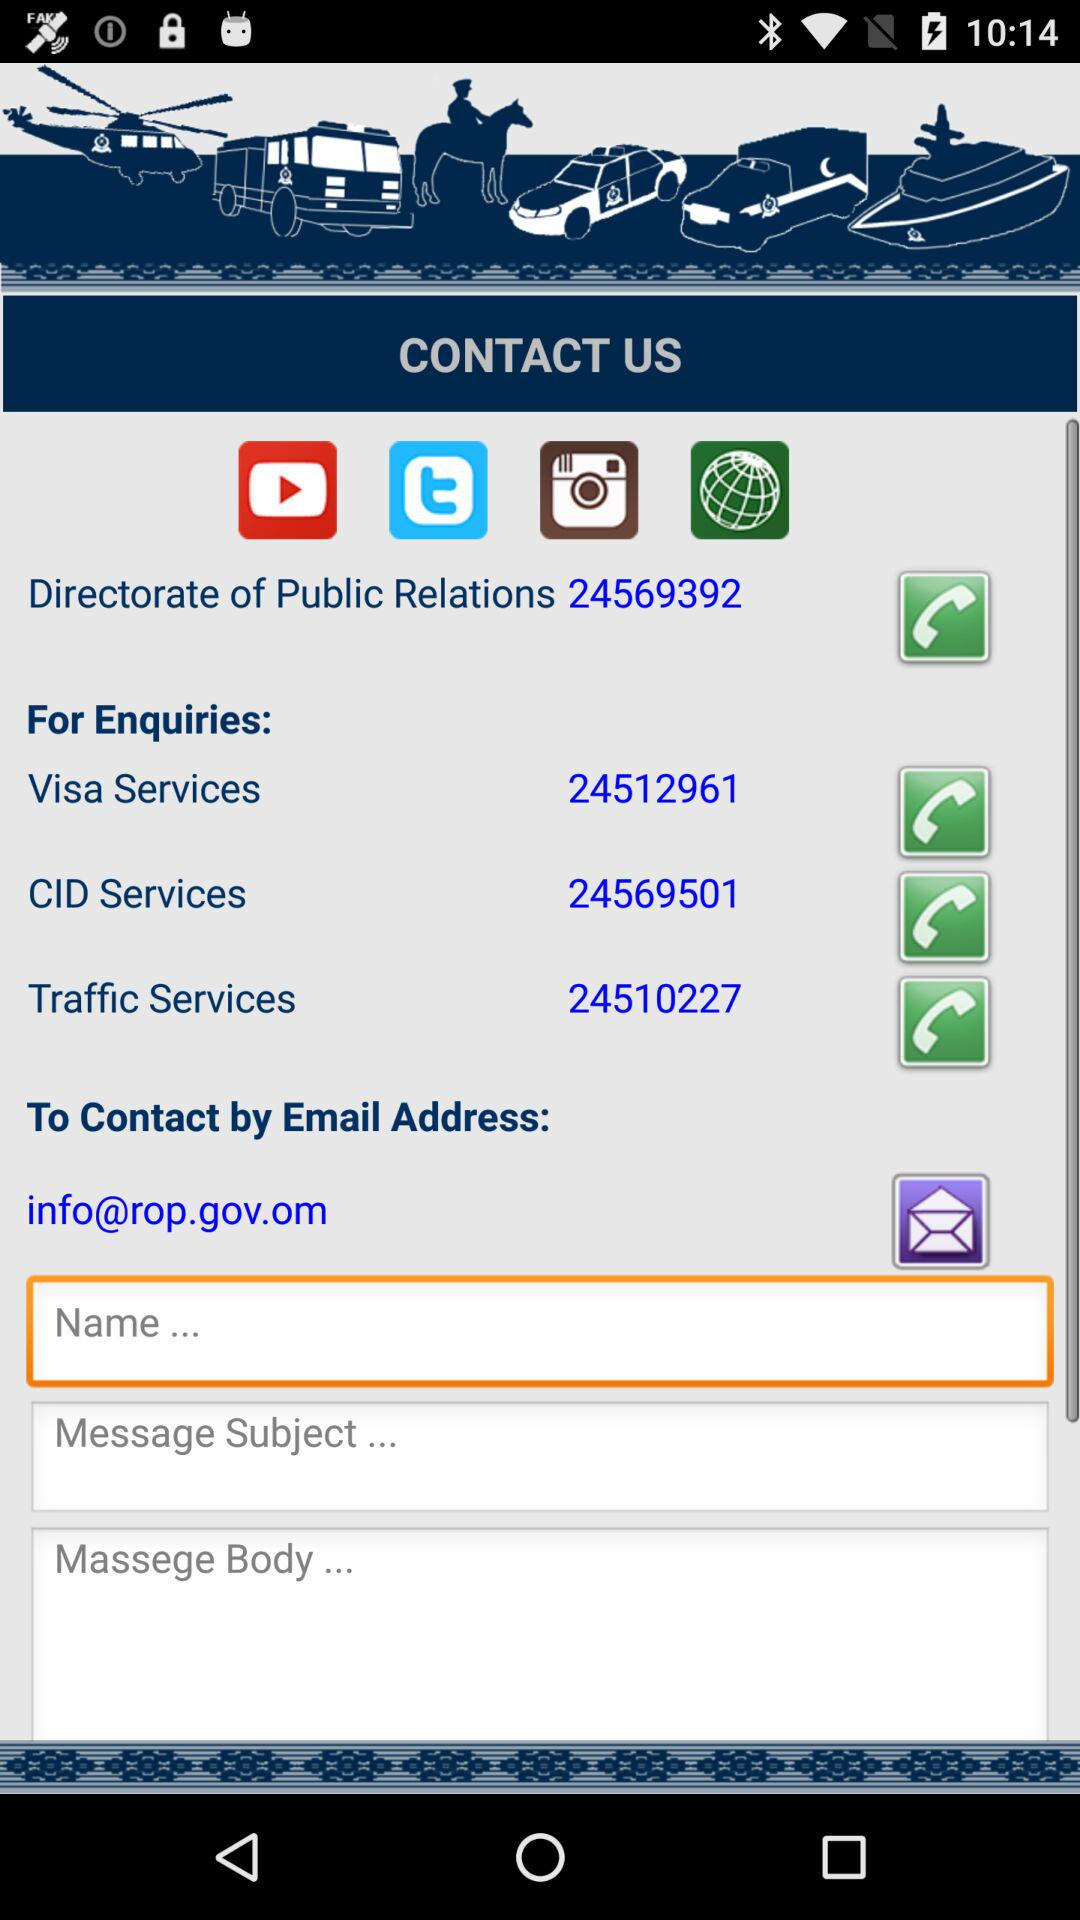How to contact with the Traffic services?
When the provided information is insufficient, respond with <no answer>. <no answer> 